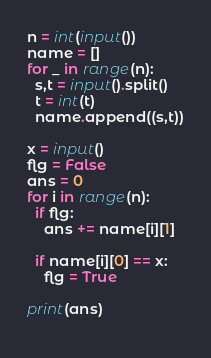<code> <loc_0><loc_0><loc_500><loc_500><_Python_>n = int(input())
name = []
for _ in range(n):
  s,t = input().split()
  t = int(t)
  name.append((s,t))
  
x = input()
flg = False
ans = 0
for i in range(n):
  if flg:
    ans += name[i][1]
    
  if name[i][0] == x:
    flg = True
    
print(ans)
    </code> 